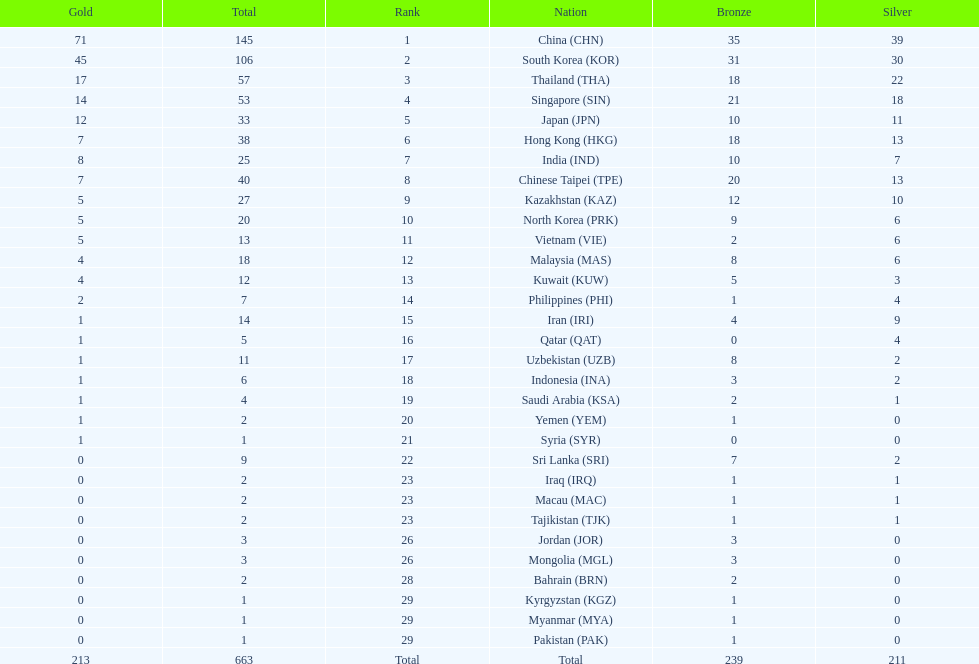How many more gold medals must qatar win before they can earn 12 gold medals? 11. Could you help me parse every detail presented in this table? {'header': ['Gold', 'Total', 'Rank', 'Nation', 'Bronze', 'Silver'], 'rows': [['71', '145', '1', 'China\xa0(CHN)', '35', '39'], ['45', '106', '2', 'South Korea\xa0(KOR)', '31', '30'], ['17', '57', '3', 'Thailand\xa0(THA)', '18', '22'], ['14', '53', '4', 'Singapore\xa0(SIN)', '21', '18'], ['12', '33', '5', 'Japan\xa0(JPN)', '10', '11'], ['7', '38', '6', 'Hong Kong\xa0(HKG)', '18', '13'], ['8', '25', '7', 'India\xa0(IND)', '10', '7'], ['7', '40', '8', 'Chinese Taipei\xa0(TPE)', '20', '13'], ['5', '27', '9', 'Kazakhstan\xa0(KAZ)', '12', '10'], ['5', '20', '10', 'North Korea\xa0(PRK)', '9', '6'], ['5', '13', '11', 'Vietnam\xa0(VIE)', '2', '6'], ['4', '18', '12', 'Malaysia\xa0(MAS)', '8', '6'], ['4', '12', '13', 'Kuwait\xa0(KUW)', '5', '3'], ['2', '7', '14', 'Philippines\xa0(PHI)', '1', '4'], ['1', '14', '15', 'Iran\xa0(IRI)', '4', '9'], ['1', '5', '16', 'Qatar\xa0(QAT)', '0', '4'], ['1', '11', '17', 'Uzbekistan\xa0(UZB)', '8', '2'], ['1', '6', '18', 'Indonesia\xa0(INA)', '3', '2'], ['1', '4', '19', 'Saudi Arabia\xa0(KSA)', '2', '1'], ['1', '2', '20', 'Yemen\xa0(YEM)', '1', '0'], ['1', '1', '21', 'Syria\xa0(SYR)', '0', '0'], ['0', '9', '22', 'Sri Lanka\xa0(SRI)', '7', '2'], ['0', '2', '23', 'Iraq\xa0(IRQ)', '1', '1'], ['0', '2', '23', 'Macau\xa0(MAC)', '1', '1'], ['0', '2', '23', 'Tajikistan\xa0(TJK)', '1', '1'], ['0', '3', '26', 'Jordan\xa0(JOR)', '3', '0'], ['0', '3', '26', 'Mongolia\xa0(MGL)', '3', '0'], ['0', '2', '28', 'Bahrain\xa0(BRN)', '2', '0'], ['0', '1', '29', 'Kyrgyzstan\xa0(KGZ)', '1', '0'], ['0', '1', '29', 'Myanmar\xa0(MYA)', '1', '0'], ['0', '1', '29', 'Pakistan\xa0(PAK)', '1', '0'], ['213', '663', 'Total', 'Total', '239', '211']]} 